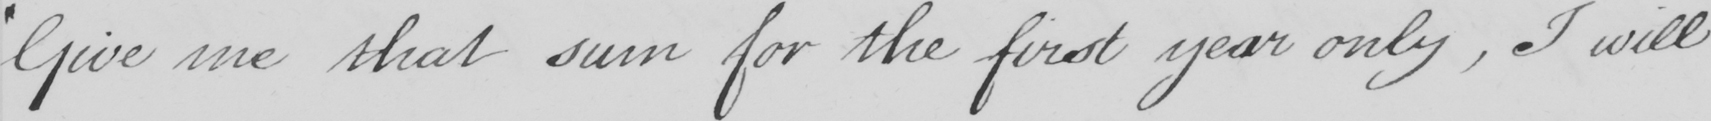Transcribe the text shown in this historical manuscript line. " Give me that sum for the first year only , I will 